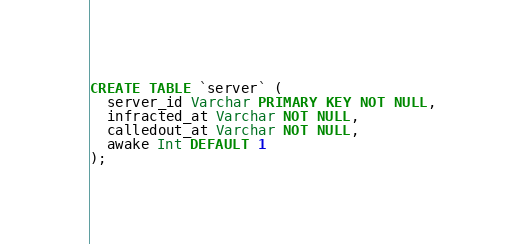Convert code to text. <code><loc_0><loc_0><loc_500><loc_500><_SQL_>CREATE TABLE `server` (
  server_id Varchar PRIMARY KEY NOT NULL,
  infracted_at Varchar NOT NULL,
  calledout_at Varchar NOT NULL,
  awake Int DEFAULT 1
);
</code> 